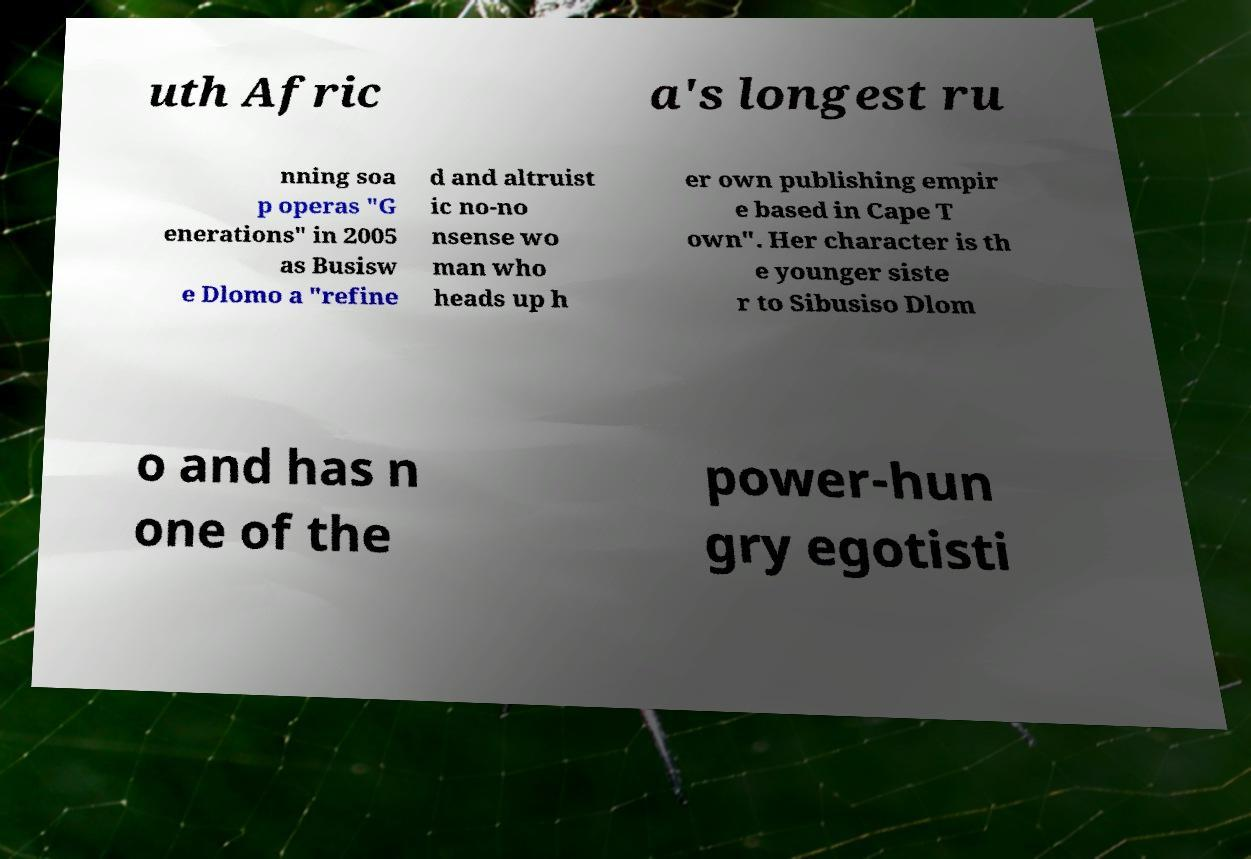There's text embedded in this image that I need extracted. Can you transcribe it verbatim? uth Afric a's longest ru nning soa p operas "G enerations" in 2005 as Busisw e Dlomo a "refine d and altruist ic no-no nsense wo man who heads up h er own publishing empir e based in Cape T own". Her character is th e younger siste r to Sibusiso Dlom o and has n one of the power-hun gry egotisti 